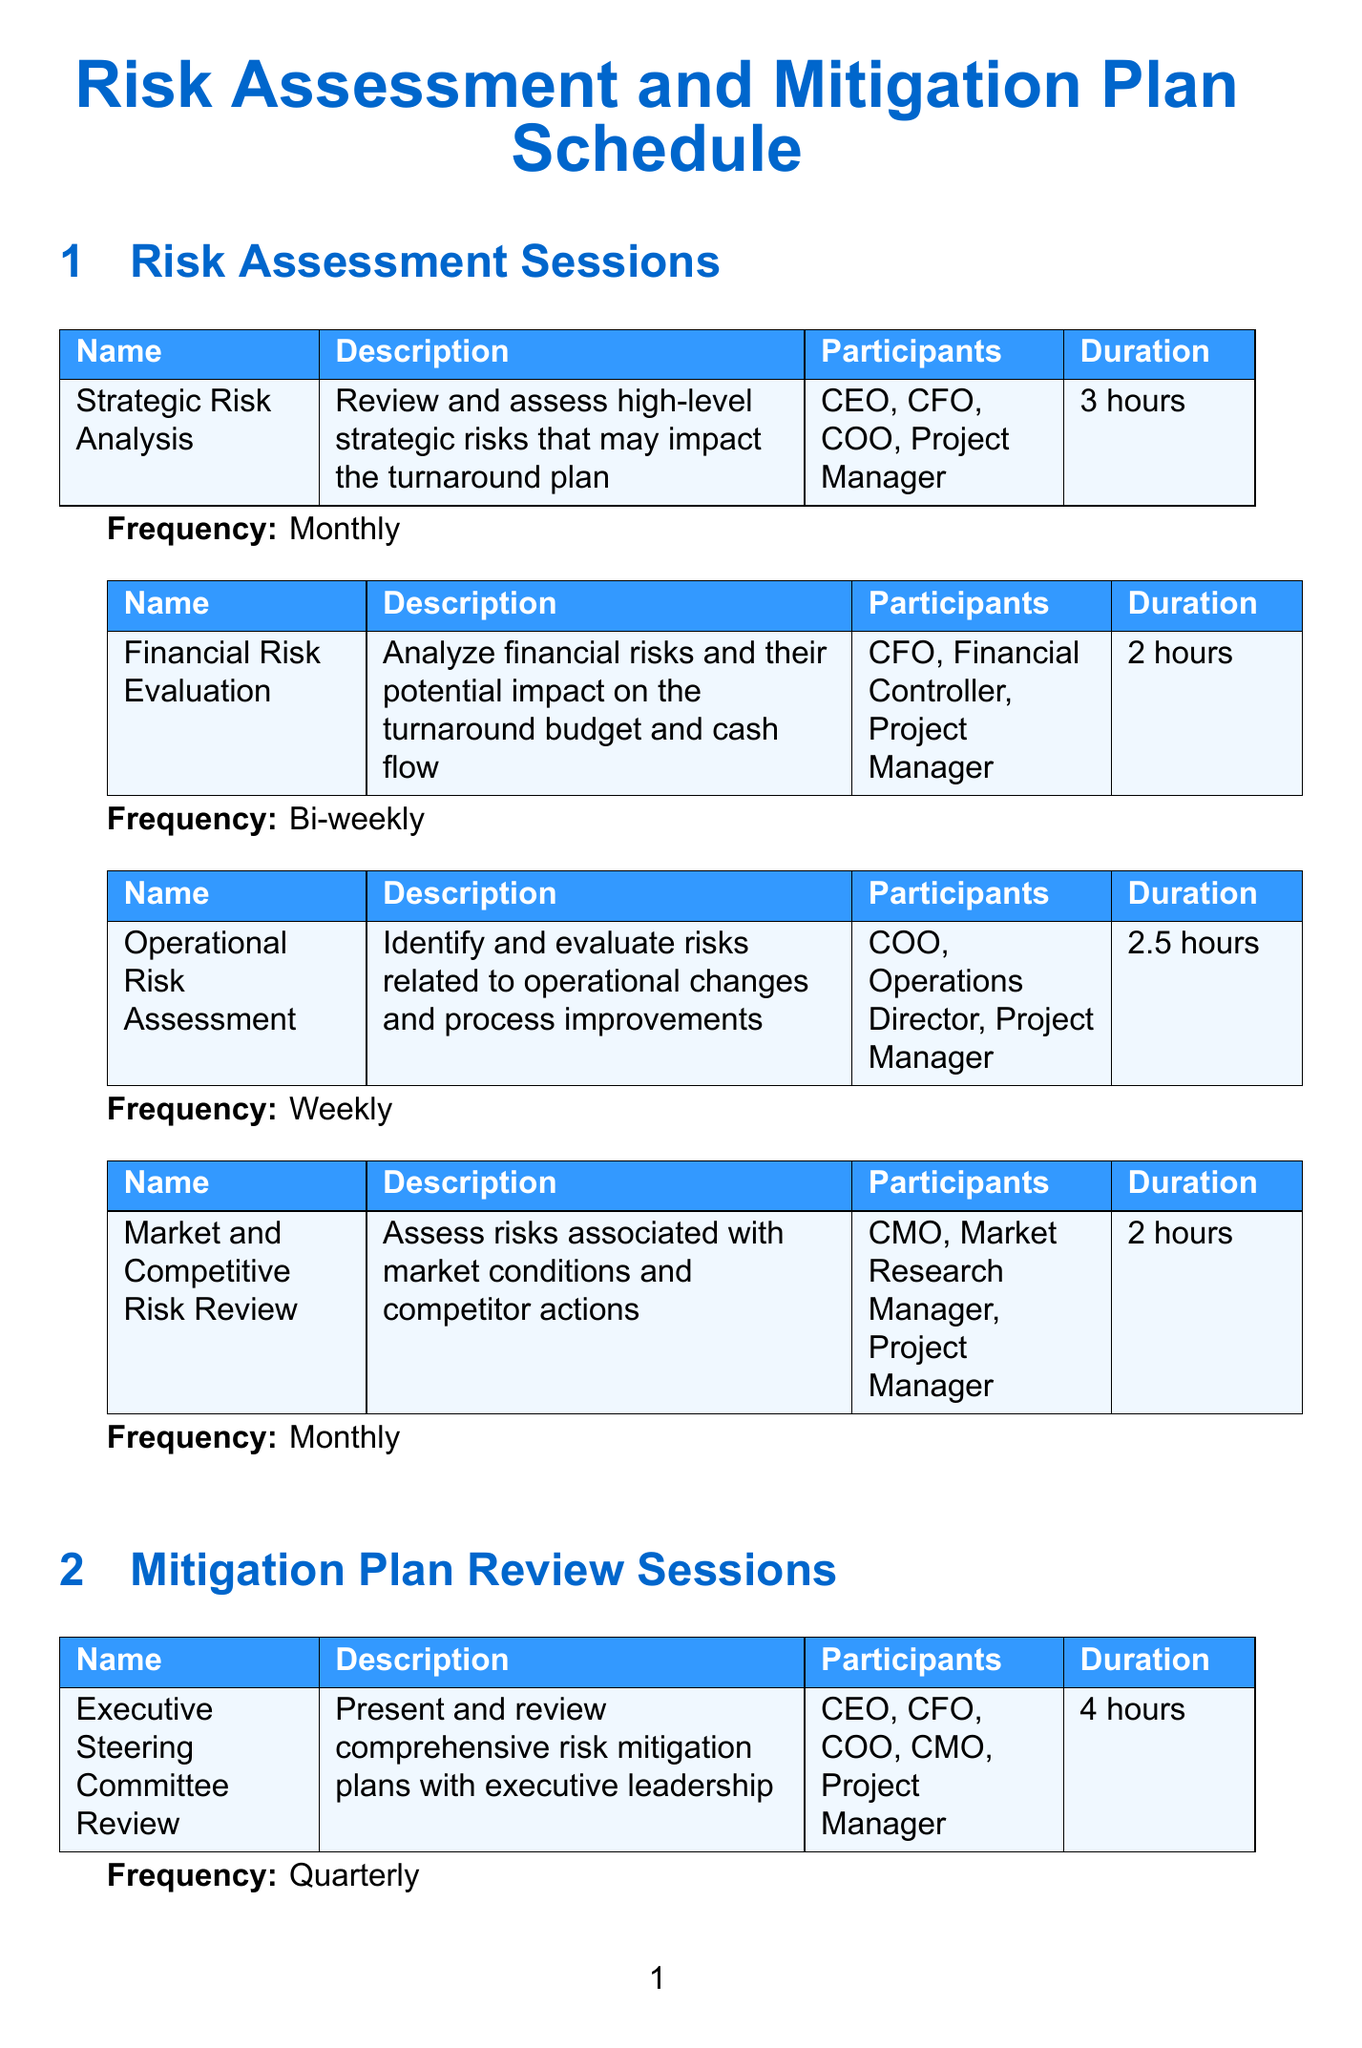What is the duration of the Strategic Risk Analysis session? The duration of the Strategic Risk Analysis session is specified in the document as 3 hours.
Answer: 3 hours How often is the Operational Risk Assessment session held? The frequency of the Operational Risk Assessment session is stated as Weekly in the document.
Answer: Weekly Who participates in the Financial Mitigation Strategies Review session? The participants of the Financial Mitigation Strategies Review session are identified in the document as CFO, Financial Planning Manager, and Project Manager.
Answer: CFO, Financial Planning Manager, Project Manager What is the primary focus of the Market and Competitive Risk Review? The document describes that the primary focus of this session is to assess risks associated with market conditions and competitor actions.
Answer: Market conditions and competitor actions How long is the External Consultant Review? The duration of the External Consultant Review session is mentioned in the document as 6 hours.
Answer: 6 hours How many participants are involved in the Executive Steering Committee Review? The document lists five participants in the Executive Steering Committee Review session.
Answer: Five What is the frequency of the Risk Management Training sessions? The document specifies that Risk Management Training sessions occur Quarterly.
Answer: Quarterly Which role is involved in all risk assessment sessions? The document indicates that the Project Manager is involved in all risk assessment sessions.
Answer: Project Manager 